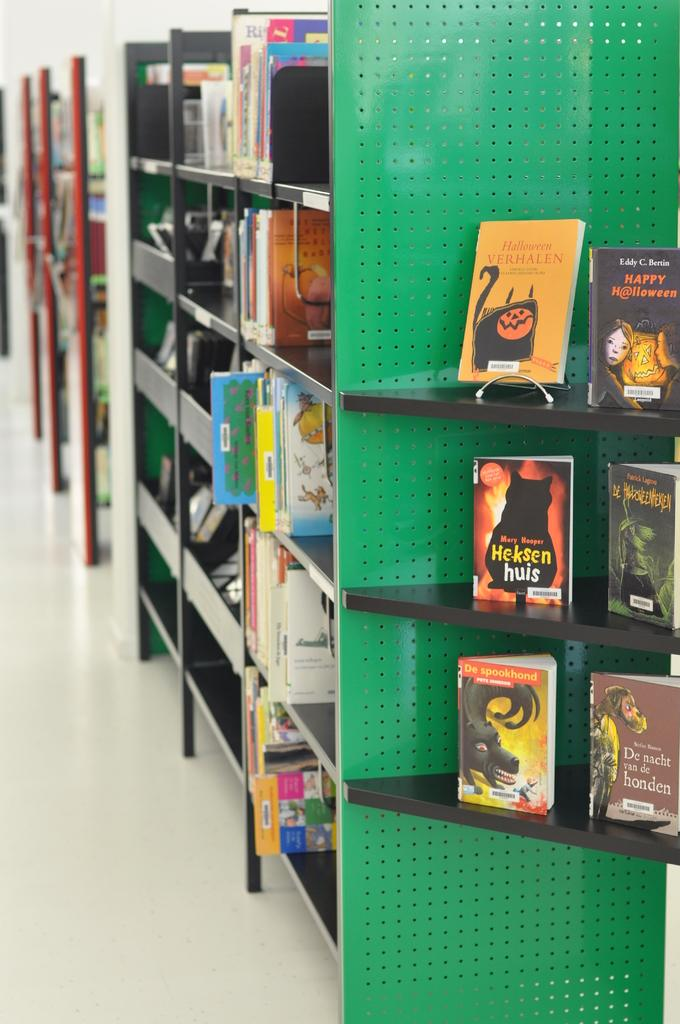<image>
Create a compact narrative representing the image presented. The orange book on the top shelf is called Halloween Verhalen. 